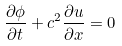<formula> <loc_0><loc_0><loc_500><loc_500>\frac { \partial \phi } { \partial t } + c ^ { 2 } \frac { \partial u } { \partial x } = 0</formula> 